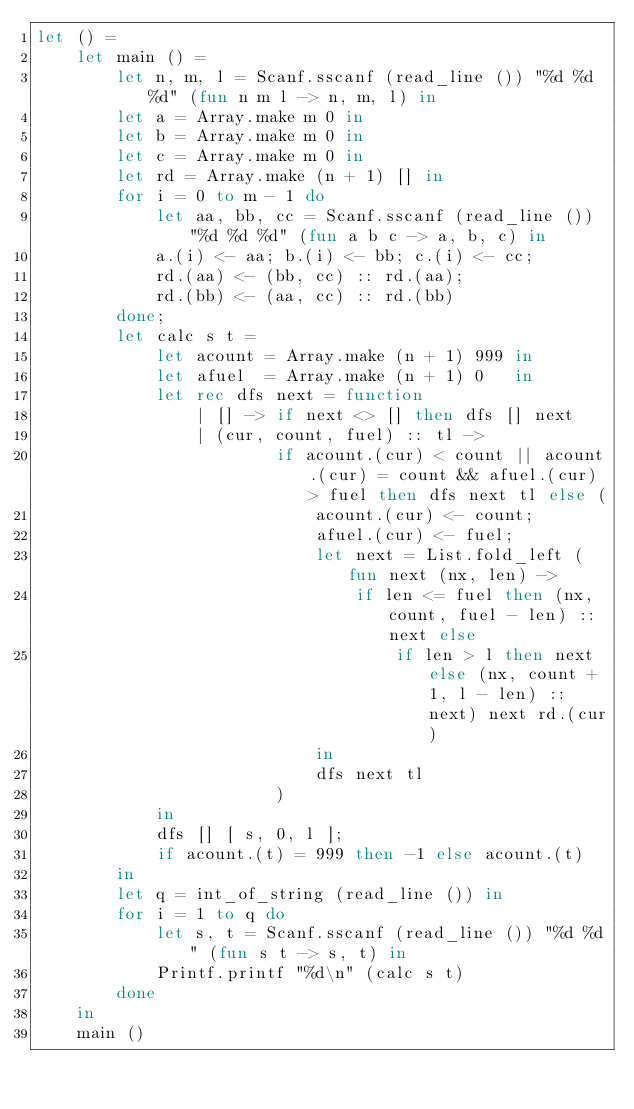<code> <loc_0><loc_0><loc_500><loc_500><_OCaml_>let () =
    let main () =
        let n, m, l = Scanf.sscanf (read_line ()) "%d %d %d" (fun n m l -> n, m, l) in
        let a = Array.make m 0 in
        let b = Array.make m 0 in
        let c = Array.make m 0 in
        let rd = Array.make (n + 1) [] in
        for i = 0 to m - 1 do
            let aa, bb, cc = Scanf.sscanf (read_line ()) "%d %d %d" (fun a b c -> a, b, c) in
            a.(i) <- aa; b.(i) <- bb; c.(i) <- cc;
            rd.(aa) <- (bb, cc) :: rd.(aa);
            rd.(bb) <- (aa, cc) :: rd.(bb)
        done;
        let calc s t =
            let acount = Array.make (n + 1) 999 in
            let afuel  = Array.make (n + 1) 0   in
            let rec dfs next = function
                | [] -> if next <> [] then dfs [] next
                | (cur, count, fuel) :: tl ->
                        if acount.(cur) < count || acount.(cur) = count && afuel.(cur) > fuel then dfs next tl else (
                            acount.(cur) <- count;
                            afuel.(cur) <- fuel;
                            let next = List.fold_left (fun next (nx, len) ->
                                if len <= fuel then (nx, count, fuel - len) :: next else
                                    if len > l then next else (nx, count + 1, l - len) :: next) next rd.(cur)
                            in
                            dfs next tl
                        )
            in
            dfs [] [ s, 0, l ];
            if acount.(t) = 999 then -1 else acount.(t)
        in
        let q = int_of_string (read_line ()) in
        for i = 1 to q do
            let s, t = Scanf.sscanf (read_line ()) "%d %d" (fun s t -> s, t) in
            Printf.printf "%d\n" (calc s t)
        done
    in
    main ()</code> 